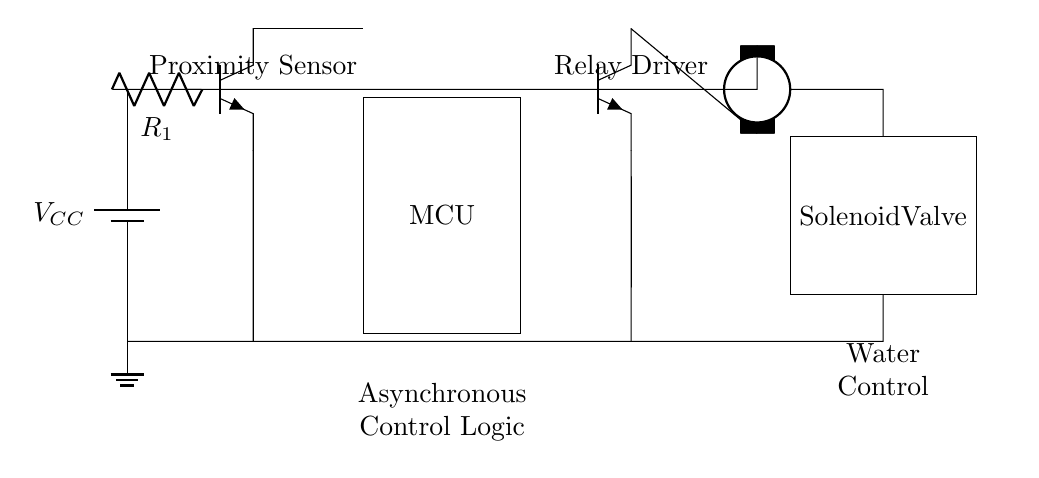What components are present in this circuit? The circuit includes a battery, a proximity sensor, a microcontroller, a relay driver, a relay, and a solenoid valve. Identifying each component through their respective symbols in the diagram leads to this conclusion.
Answer: Battery, proximity sensor, microcontroller, relay driver, relay, solenoid valve What is the role of the proximity sensor? The proximity sensor detects the presence of a user to activate the water fountain. It serves as an input device that triggers the control logic in the microcontroller when a person is near.
Answer: User detection How many power supply terminals are there in this circuit? There is one battery, which provides a single power supply terminal (V_CC). This terminal connects all other components to a common power source in the circuit.
Answer: One What is the output of the microcontroller? The microcontroller outputs a control signal to the relay driver. This signal activates the relay driver based on the input from the proximity sensor, allowing for water flow control.
Answer: Control signal What type of control logic is used in this circuit? The control logic implemented in this circuit is asynchronous. This means that the operation of the microcontroller does not rely on clock signals to manage the water flow based on real-time user detection.
Answer: Asynchronous control Which component directly controls the flow of water? The solenoid valve directly controls the flow of water. When activated by the relay, it opens to allow water to flow from the fountain when a user is detected.
Answer: Solenoid valve 